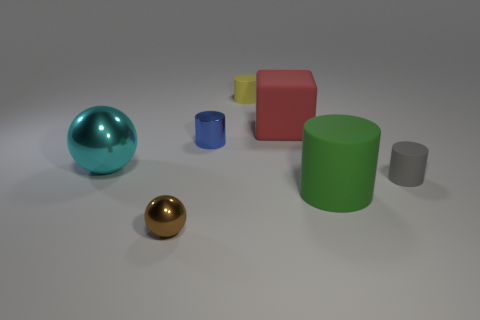What number of other objects are there of the same color as the small shiny sphere?
Your response must be concise. 0. What is the size of the ball behind the tiny rubber thing in front of the big rubber cube on the left side of the green cylinder?
Offer a very short reply. Large. There is a red thing that is made of the same material as the large cylinder; what size is it?
Keep it short and to the point. Large. There is a cylinder that is left of the matte block and in front of the big red matte cube; what color is it?
Your response must be concise. Blue. There is a metal thing that is on the right side of the tiny brown metallic ball; is its shape the same as the object that is to the left of the small brown sphere?
Give a very brief answer. No. What material is the sphere in front of the large cylinder?
Offer a terse response. Metal. What number of things are either small metal things that are behind the small brown metal object or metal cylinders?
Your response must be concise. 1. Is the number of small metal cylinders in front of the brown metallic sphere the same as the number of big yellow matte objects?
Keep it short and to the point. Yes. Is the size of the yellow rubber thing the same as the green rubber thing?
Your answer should be very brief. No. There is a matte cylinder that is the same size as the cyan ball; what color is it?
Give a very brief answer. Green. 